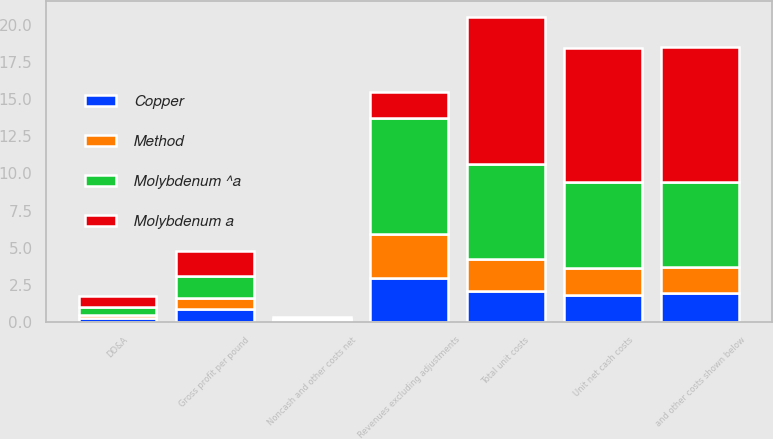<chart> <loc_0><loc_0><loc_500><loc_500><stacked_bar_chart><ecel><fcel>Revenues excluding adjustments<fcel>and other costs shown below<fcel>Unit net cash costs<fcel>DD&A<fcel>Noncash and other costs net<fcel>Total unit costs<fcel>Gross profit per pound<nl><fcel>Copper<fcel>2.96<fcel>1.94<fcel>1.79<fcel>0.25<fcel>0.07<fcel>2.11<fcel>0.85<nl><fcel>Method<fcel>2.96<fcel>1.77<fcel>1.87<fcel>0.23<fcel>0.06<fcel>2.16<fcel>0.8<nl><fcel>Molybdenum a<fcel>1.79<fcel>9.03<fcel>9.03<fcel>0.73<fcel>0.17<fcel>9.93<fcel>1.71<nl><fcel>Molybdenum ^a<fcel>7.8<fcel>5.75<fcel>5.75<fcel>0.54<fcel>0.07<fcel>6.36<fcel>1.44<nl></chart> 